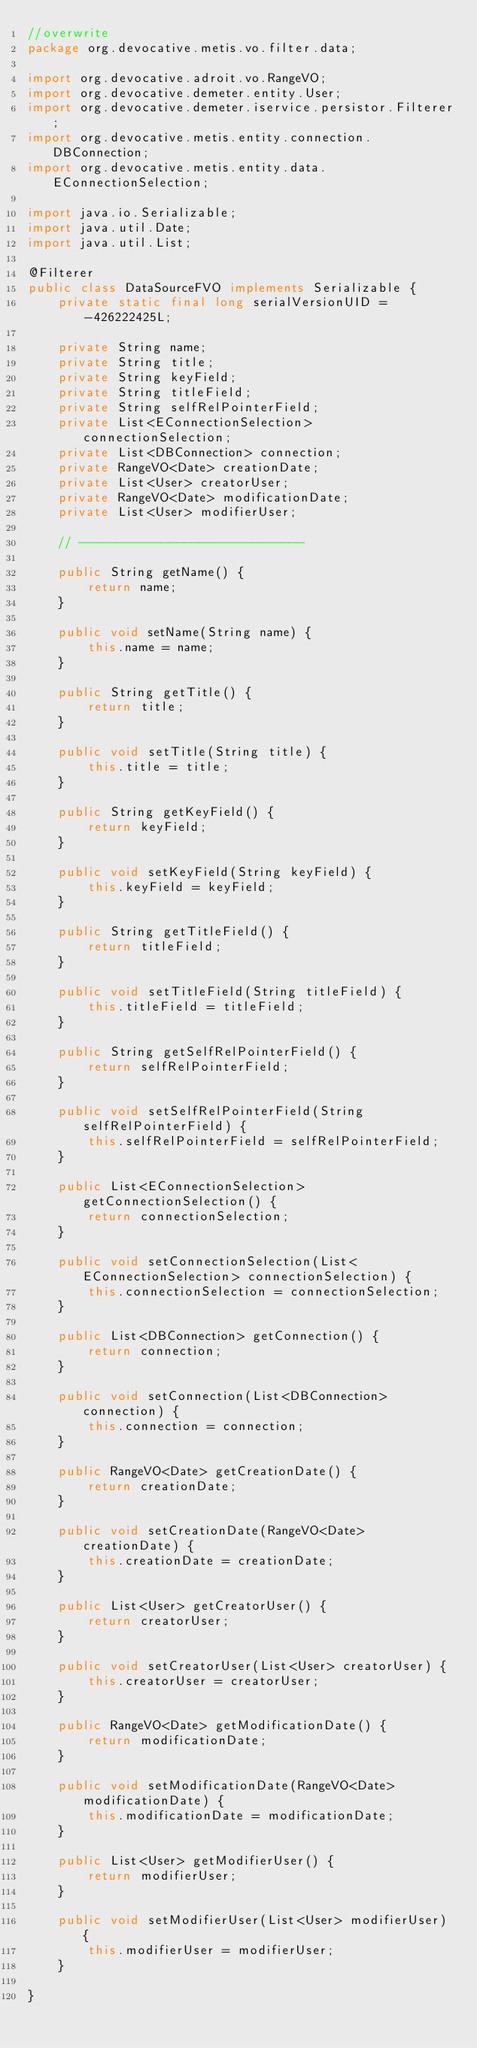Convert code to text. <code><loc_0><loc_0><loc_500><loc_500><_Java_>//overwrite
package org.devocative.metis.vo.filter.data;

import org.devocative.adroit.vo.RangeVO;
import org.devocative.demeter.entity.User;
import org.devocative.demeter.iservice.persistor.Filterer;
import org.devocative.metis.entity.connection.DBConnection;
import org.devocative.metis.entity.data.EConnectionSelection;

import java.io.Serializable;
import java.util.Date;
import java.util.List;

@Filterer
public class DataSourceFVO implements Serializable {
	private static final long serialVersionUID = -426222425L;

	private String name;
	private String title;
	private String keyField;
	private String titleField;
	private String selfRelPointerField;
	private List<EConnectionSelection> connectionSelection;
	private List<DBConnection> connection;
	private RangeVO<Date> creationDate;
	private List<User> creatorUser;
	private RangeVO<Date> modificationDate;
	private List<User> modifierUser;

	// ------------------------------

	public String getName() {
		return name;
	}

	public void setName(String name) {
		this.name = name;
	}

	public String getTitle() {
		return title;
	}

	public void setTitle(String title) {
		this.title = title;
	}

	public String getKeyField() {
		return keyField;
	}

	public void setKeyField(String keyField) {
		this.keyField = keyField;
	}

	public String getTitleField() {
		return titleField;
	}

	public void setTitleField(String titleField) {
		this.titleField = titleField;
	}

	public String getSelfRelPointerField() {
		return selfRelPointerField;
	}

	public void setSelfRelPointerField(String selfRelPointerField) {
		this.selfRelPointerField = selfRelPointerField;
	}

	public List<EConnectionSelection> getConnectionSelection() {
		return connectionSelection;
	}

	public void setConnectionSelection(List<EConnectionSelection> connectionSelection) {
		this.connectionSelection = connectionSelection;
	}

	public List<DBConnection> getConnection() {
		return connection;
	}

	public void setConnection(List<DBConnection> connection) {
		this.connection = connection;
	}

	public RangeVO<Date> getCreationDate() {
		return creationDate;
	}

	public void setCreationDate(RangeVO<Date> creationDate) {
		this.creationDate = creationDate;
	}

	public List<User> getCreatorUser() {
		return creatorUser;
	}

	public void setCreatorUser(List<User> creatorUser) {
		this.creatorUser = creatorUser;
	}

	public RangeVO<Date> getModificationDate() {
		return modificationDate;
	}

	public void setModificationDate(RangeVO<Date> modificationDate) {
		this.modificationDate = modificationDate;
	}

	public List<User> getModifierUser() {
		return modifierUser;
	}

	public void setModifierUser(List<User> modifierUser) {
		this.modifierUser = modifierUser;
	}

}
</code> 